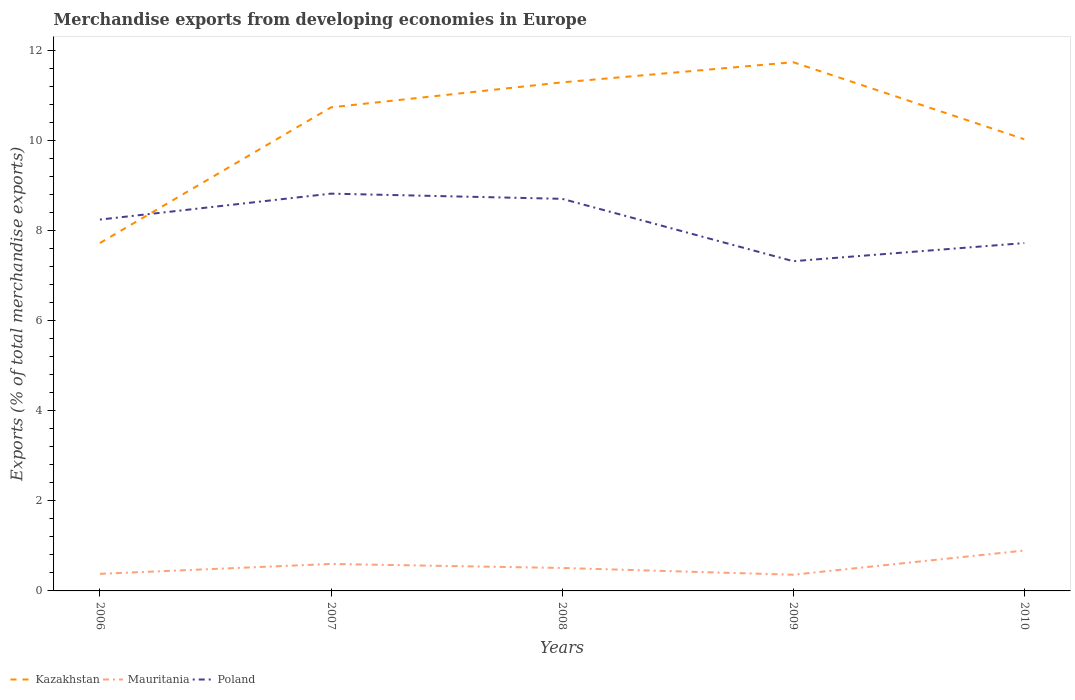How many different coloured lines are there?
Provide a succinct answer. 3. Does the line corresponding to Poland intersect with the line corresponding to Kazakhstan?
Your answer should be very brief. Yes. Across all years, what is the maximum percentage of total merchandise exports in Poland?
Your response must be concise. 7.32. In which year was the percentage of total merchandise exports in Mauritania maximum?
Provide a short and direct response. 2009. What is the total percentage of total merchandise exports in Mauritania in the graph?
Make the answer very short. 0.09. What is the difference between the highest and the second highest percentage of total merchandise exports in Poland?
Your answer should be very brief. 1.5. What is the difference between the highest and the lowest percentage of total merchandise exports in Mauritania?
Make the answer very short. 2. Is the percentage of total merchandise exports in Poland strictly greater than the percentage of total merchandise exports in Kazakhstan over the years?
Make the answer very short. No. How many years are there in the graph?
Ensure brevity in your answer.  5. Does the graph contain grids?
Your answer should be compact. No. What is the title of the graph?
Your answer should be very brief. Merchandise exports from developing economies in Europe. Does "Lithuania" appear as one of the legend labels in the graph?
Provide a succinct answer. No. What is the label or title of the X-axis?
Give a very brief answer. Years. What is the label or title of the Y-axis?
Provide a short and direct response. Exports (% of total merchandise exports). What is the Exports (% of total merchandise exports) in Kazakhstan in 2006?
Your response must be concise. 7.72. What is the Exports (% of total merchandise exports) of Mauritania in 2006?
Your response must be concise. 0.38. What is the Exports (% of total merchandise exports) in Poland in 2006?
Offer a very short reply. 8.24. What is the Exports (% of total merchandise exports) in Kazakhstan in 2007?
Provide a short and direct response. 10.73. What is the Exports (% of total merchandise exports) of Mauritania in 2007?
Offer a very short reply. 0.6. What is the Exports (% of total merchandise exports) in Poland in 2007?
Provide a short and direct response. 8.81. What is the Exports (% of total merchandise exports) in Kazakhstan in 2008?
Make the answer very short. 11.28. What is the Exports (% of total merchandise exports) of Mauritania in 2008?
Your response must be concise. 0.51. What is the Exports (% of total merchandise exports) of Poland in 2008?
Ensure brevity in your answer.  8.7. What is the Exports (% of total merchandise exports) in Kazakhstan in 2009?
Your answer should be very brief. 11.73. What is the Exports (% of total merchandise exports) of Mauritania in 2009?
Ensure brevity in your answer.  0.36. What is the Exports (% of total merchandise exports) in Poland in 2009?
Provide a short and direct response. 7.32. What is the Exports (% of total merchandise exports) of Kazakhstan in 2010?
Your answer should be very brief. 10.02. What is the Exports (% of total merchandise exports) in Mauritania in 2010?
Keep it short and to the point. 0.9. What is the Exports (% of total merchandise exports) in Poland in 2010?
Your response must be concise. 7.72. Across all years, what is the maximum Exports (% of total merchandise exports) of Kazakhstan?
Offer a very short reply. 11.73. Across all years, what is the maximum Exports (% of total merchandise exports) in Mauritania?
Offer a terse response. 0.9. Across all years, what is the maximum Exports (% of total merchandise exports) in Poland?
Your answer should be very brief. 8.81. Across all years, what is the minimum Exports (% of total merchandise exports) in Kazakhstan?
Keep it short and to the point. 7.72. Across all years, what is the minimum Exports (% of total merchandise exports) of Mauritania?
Your answer should be compact. 0.36. Across all years, what is the minimum Exports (% of total merchandise exports) of Poland?
Make the answer very short. 7.32. What is the total Exports (% of total merchandise exports) of Kazakhstan in the graph?
Your answer should be compact. 51.49. What is the total Exports (% of total merchandise exports) in Mauritania in the graph?
Give a very brief answer. 2.74. What is the total Exports (% of total merchandise exports) of Poland in the graph?
Provide a short and direct response. 40.79. What is the difference between the Exports (% of total merchandise exports) in Kazakhstan in 2006 and that in 2007?
Your answer should be very brief. -3.01. What is the difference between the Exports (% of total merchandise exports) of Mauritania in 2006 and that in 2007?
Give a very brief answer. -0.22. What is the difference between the Exports (% of total merchandise exports) of Poland in 2006 and that in 2007?
Your answer should be compact. -0.58. What is the difference between the Exports (% of total merchandise exports) in Kazakhstan in 2006 and that in 2008?
Give a very brief answer. -3.56. What is the difference between the Exports (% of total merchandise exports) of Mauritania in 2006 and that in 2008?
Ensure brevity in your answer.  -0.13. What is the difference between the Exports (% of total merchandise exports) of Poland in 2006 and that in 2008?
Your answer should be compact. -0.46. What is the difference between the Exports (% of total merchandise exports) in Kazakhstan in 2006 and that in 2009?
Keep it short and to the point. -4.01. What is the difference between the Exports (% of total merchandise exports) in Mauritania in 2006 and that in 2009?
Offer a terse response. 0.02. What is the difference between the Exports (% of total merchandise exports) in Poland in 2006 and that in 2009?
Your answer should be compact. 0.92. What is the difference between the Exports (% of total merchandise exports) in Kazakhstan in 2006 and that in 2010?
Your response must be concise. -2.3. What is the difference between the Exports (% of total merchandise exports) of Mauritania in 2006 and that in 2010?
Ensure brevity in your answer.  -0.52. What is the difference between the Exports (% of total merchandise exports) in Poland in 2006 and that in 2010?
Your answer should be very brief. 0.52. What is the difference between the Exports (% of total merchandise exports) of Kazakhstan in 2007 and that in 2008?
Your answer should be very brief. -0.55. What is the difference between the Exports (% of total merchandise exports) in Mauritania in 2007 and that in 2008?
Provide a succinct answer. 0.09. What is the difference between the Exports (% of total merchandise exports) of Poland in 2007 and that in 2008?
Offer a very short reply. 0.12. What is the difference between the Exports (% of total merchandise exports) of Kazakhstan in 2007 and that in 2009?
Your answer should be very brief. -1. What is the difference between the Exports (% of total merchandise exports) of Mauritania in 2007 and that in 2009?
Offer a terse response. 0.24. What is the difference between the Exports (% of total merchandise exports) in Poland in 2007 and that in 2009?
Your answer should be very brief. 1.5. What is the difference between the Exports (% of total merchandise exports) of Kazakhstan in 2007 and that in 2010?
Provide a short and direct response. 0.71. What is the difference between the Exports (% of total merchandise exports) of Mauritania in 2007 and that in 2010?
Provide a short and direct response. -0.3. What is the difference between the Exports (% of total merchandise exports) in Poland in 2007 and that in 2010?
Give a very brief answer. 1.1. What is the difference between the Exports (% of total merchandise exports) in Kazakhstan in 2008 and that in 2009?
Your response must be concise. -0.45. What is the difference between the Exports (% of total merchandise exports) in Mauritania in 2008 and that in 2009?
Give a very brief answer. 0.15. What is the difference between the Exports (% of total merchandise exports) in Poland in 2008 and that in 2009?
Provide a short and direct response. 1.38. What is the difference between the Exports (% of total merchandise exports) in Kazakhstan in 2008 and that in 2010?
Your answer should be compact. 1.26. What is the difference between the Exports (% of total merchandise exports) in Mauritania in 2008 and that in 2010?
Your answer should be very brief. -0.39. What is the difference between the Exports (% of total merchandise exports) in Poland in 2008 and that in 2010?
Keep it short and to the point. 0.98. What is the difference between the Exports (% of total merchandise exports) in Kazakhstan in 2009 and that in 2010?
Offer a terse response. 1.71. What is the difference between the Exports (% of total merchandise exports) in Mauritania in 2009 and that in 2010?
Provide a succinct answer. -0.54. What is the difference between the Exports (% of total merchandise exports) of Poland in 2009 and that in 2010?
Your response must be concise. -0.4. What is the difference between the Exports (% of total merchandise exports) of Kazakhstan in 2006 and the Exports (% of total merchandise exports) of Mauritania in 2007?
Offer a very short reply. 7.12. What is the difference between the Exports (% of total merchandise exports) in Kazakhstan in 2006 and the Exports (% of total merchandise exports) in Poland in 2007?
Provide a succinct answer. -1.1. What is the difference between the Exports (% of total merchandise exports) in Mauritania in 2006 and the Exports (% of total merchandise exports) in Poland in 2007?
Ensure brevity in your answer.  -8.44. What is the difference between the Exports (% of total merchandise exports) in Kazakhstan in 2006 and the Exports (% of total merchandise exports) in Mauritania in 2008?
Your answer should be very brief. 7.21. What is the difference between the Exports (% of total merchandise exports) of Kazakhstan in 2006 and the Exports (% of total merchandise exports) of Poland in 2008?
Offer a terse response. -0.98. What is the difference between the Exports (% of total merchandise exports) in Mauritania in 2006 and the Exports (% of total merchandise exports) in Poland in 2008?
Provide a succinct answer. -8.32. What is the difference between the Exports (% of total merchandise exports) in Kazakhstan in 2006 and the Exports (% of total merchandise exports) in Mauritania in 2009?
Keep it short and to the point. 7.36. What is the difference between the Exports (% of total merchandise exports) of Kazakhstan in 2006 and the Exports (% of total merchandise exports) of Poland in 2009?
Provide a short and direct response. 0.4. What is the difference between the Exports (% of total merchandise exports) of Mauritania in 2006 and the Exports (% of total merchandise exports) of Poland in 2009?
Your answer should be very brief. -6.94. What is the difference between the Exports (% of total merchandise exports) of Kazakhstan in 2006 and the Exports (% of total merchandise exports) of Mauritania in 2010?
Provide a succinct answer. 6.82. What is the difference between the Exports (% of total merchandise exports) of Kazakhstan in 2006 and the Exports (% of total merchandise exports) of Poland in 2010?
Your answer should be compact. 0. What is the difference between the Exports (% of total merchandise exports) of Mauritania in 2006 and the Exports (% of total merchandise exports) of Poland in 2010?
Provide a succinct answer. -7.34. What is the difference between the Exports (% of total merchandise exports) in Kazakhstan in 2007 and the Exports (% of total merchandise exports) in Mauritania in 2008?
Offer a very short reply. 10.22. What is the difference between the Exports (% of total merchandise exports) of Kazakhstan in 2007 and the Exports (% of total merchandise exports) of Poland in 2008?
Keep it short and to the point. 2.03. What is the difference between the Exports (% of total merchandise exports) in Mauritania in 2007 and the Exports (% of total merchandise exports) in Poland in 2008?
Keep it short and to the point. -8.1. What is the difference between the Exports (% of total merchandise exports) of Kazakhstan in 2007 and the Exports (% of total merchandise exports) of Mauritania in 2009?
Provide a short and direct response. 10.37. What is the difference between the Exports (% of total merchandise exports) in Kazakhstan in 2007 and the Exports (% of total merchandise exports) in Poland in 2009?
Make the answer very short. 3.41. What is the difference between the Exports (% of total merchandise exports) in Mauritania in 2007 and the Exports (% of total merchandise exports) in Poland in 2009?
Offer a terse response. -6.72. What is the difference between the Exports (% of total merchandise exports) of Kazakhstan in 2007 and the Exports (% of total merchandise exports) of Mauritania in 2010?
Keep it short and to the point. 9.83. What is the difference between the Exports (% of total merchandise exports) of Kazakhstan in 2007 and the Exports (% of total merchandise exports) of Poland in 2010?
Offer a terse response. 3.01. What is the difference between the Exports (% of total merchandise exports) of Mauritania in 2007 and the Exports (% of total merchandise exports) of Poland in 2010?
Make the answer very short. -7.12. What is the difference between the Exports (% of total merchandise exports) of Kazakhstan in 2008 and the Exports (% of total merchandise exports) of Mauritania in 2009?
Ensure brevity in your answer.  10.92. What is the difference between the Exports (% of total merchandise exports) in Kazakhstan in 2008 and the Exports (% of total merchandise exports) in Poland in 2009?
Provide a short and direct response. 3.97. What is the difference between the Exports (% of total merchandise exports) of Mauritania in 2008 and the Exports (% of total merchandise exports) of Poland in 2009?
Ensure brevity in your answer.  -6.81. What is the difference between the Exports (% of total merchandise exports) of Kazakhstan in 2008 and the Exports (% of total merchandise exports) of Mauritania in 2010?
Keep it short and to the point. 10.39. What is the difference between the Exports (% of total merchandise exports) in Kazakhstan in 2008 and the Exports (% of total merchandise exports) in Poland in 2010?
Provide a succinct answer. 3.57. What is the difference between the Exports (% of total merchandise exports) in Mauritania in 2008 and the Exports (% of total merchandise exports) in Poland in 2010?
Your answer should be very brief. -7.21. What is the difference between the Exports (% of total merchandise exports) of Kazakhstan in 2009 and the Exports (% of total merchandise exports) of Mauritania in 2010?
Your response must be concise. 10.84. What is the difference between the Exports (% of total merchandise exports) in Kazakhstan in 2009 and the Exports (% of total merchandise exports) in Poland in 2010?
Your answer should be very brief. 4.01. What is the difference between the Exports (% of total merchandise exports) of Mauritania in 2009 and the Exports (% of total merchandise exports) of Poland in 2010?
Keep it short and to the point. -7.36. What is the average Exports (% of total merchandise exports) of Kazakhstan per year?
Provide a succinct answer. 10.3. What is the average Exports (% of total merchandise exports) in Mauritania per year?
Provide a short and direct response. 0.55. What is the average Exports (% of total merchandise exports) of Poland per year?
Your answer should be compact. 8.16. In the year 2006, what is the difference between the Exports (% of total merchandise exports) of Kazakhstan and Exports (% of total merchandise exports) of Mauritania?
Your response must be concise. 7.34. In the year 2006, what is the difference between the Exports (% of total merchandise exports) in Kazakhstan and Exports (% of total merchandise exports) in Poland?
Offer a terse response. -0.52. In the year 2006, what is the difference between the Exports (% of total merchandise exports) of Mauritania and Exports (% of total merchandise exports) of Poland?
Keep it short and to the point. -7.86. In the year 2007, what is the difference between the Exports (% of total merchandise exports) in Kazakhstan and Exports (% of total merchandise exports) in Mauritania?
Ensure brevity in your answer.  10.13. In the year 2007, what is the difference between the Exports (% of total merchandise exports) of Kazakhstan and Exports (% of total merchandise exports) of Poland?
Keep it short and to the point. 1.91. In the year 2007, what is the difference between the Exports (% of total merchandise exports) in Mauritania and Exports (% of total merchandise exports) in Poland?
Your response must be concise. -8.22. In the year 2008, what is the difference between the Exports (% of total merchandise exports) of Kazakhstan and Exports (% of total merchandise exports) of Mauritania?
Provide a succinct answer. 10.77. In the year 2008, what is the difference between the Exports (% of total merchandise exports) of Kazakhstan and Exports (% of total merchandise exports) of Poland?
Offer a very short reply. 2.58. In the year 2008, what is the difference between the Exports (% of total merchandise exports) in Mauritania and Exports (% of total merchandise exports) in Poland?
Offer a very short reply. -8.19. In the year 2009, what is the difference between the Exports (% of total merchandise exports) of Kazakhstan and Exports (% of total merchandise exports) of Mauritania?
Make the answer very short. 11.37. In the year 2009, what is the difference between the Exports (% of total merchandise exports) of Kazakhstan and Exports (% of total merchandise exports) of Poland?
Your answer should be very brief. 4.42. In the year 2009, what is the difference between the Exports (% of total merchandise exports) in Mauritania and Exports (% of total merchandise exports) in Poland?
Offer a terse response. -6.96. In the year 2010, what is the difference between the Exports (% of total merchandise exports) in Kazakhstan and Exports (% of total merchandise exports) in Mauritania?
Provide a succinct answer. 9.13. In the year 2010, what is the difference between the Exports (% of total merchandise exports) in Kazakhstan and Exports (% of total merchandise exports) in Poland?
Provide a short and direct response. 2.3. In the year 2010, what is the difference between the Exports (% of total merchandise exports) in Mauritania and Exports (% of total merchandise exports) in Poland?
Offer a terse response. -6.82. What is the ratio of the Exports (% of total merchandise exports) of Kazakhstan in 2006 to that in 2007?
Provide a short and direct response. 0.72. What is the ratio of the Exports (% of total merchandise exports) in Mauritania in 2006 to that in 2007?
Offer a very short reply. 0.63. What is the ratio of the Exports (% of total merchandise exports) of Poland in 2006 to that in 2007?
Keep it short and to the point. 0.93. What is the ratio of the Exports (% of total merchandise exports) in Kazakhstan in 2006 to that in 2008?
Provide a short and direct response. 0.68. What is the ratio of the Exports (% of total merchandise exports) of Mauritania in 2006 to that in 2008?
Offer a very short reply. 0.74. What is the ratio of the Exports (% of total merchandise exports) of Poland in 2006 to that in 2008?
Your answer should be very brief. 0.95. What is the ratio of the Exports (% of total merchandise exports) in Kazakhstan in 2006 to that in 2009?
Your response must be concise. 0.66. What is the ratio of the Exports (% of total merchandise exports) of Mauritania in 2006 to that in 2009?
Your answer should be compact. 1.05. What is the ratio of the Exports (% of total merchandise exports) of Poland in 2006 to that in 2009?
Your response must be concise. 1.13. What is the ratio of the Exports (% of total merchandise exports) of Kazakhstan in 2006 to that in 2010?
Make the answer very short. 0.77. What is the ratio of the Exports (% of total merchandise exports) in Mauritania in 2006 to that in 2010?
Provide a succinct answer. 0.42. What is the ratio of the Exports (% of total merchandise exports) of Poland in 2006 to that in 2010?
Provide a short and direct response. 1.07. What is the ratio of the Exports (% of total merchandise exports) in Kazakhstan in 2007 to that in 2008?
Your answer should be very brief. 0.95. What is the ratio of the Exports (% of total merchandise exports) in Mauritania in 2007 to that in 2008?
Provide a short and direct response. 1.18. What is the ratio of the Exports (% of total merchandise exports) in Poland in 2007 to that in 2008?
Provide a succinct answer. 1.01. What is the ratio of the Exports (% of total merchandise exports) in Kazakhstan in 2007 to that in 2009?
Offer a terse response. 0.91. What is the ratio of the Exports (% of total merchandise exports) of Mauritania in 2007 to that in 2009?
Give a very brief answer. 1.67. What is the ratio of the Exports (% of total merchandise exports) in Poland in 2007 to that in 2009?
Provide a short and direct response. 1.2. What is the ratio of the Exports (% of total merchandise exports) in Kazakhstan in 2007 to that in 2010?
Keep it short and to the point. 1.07. What is the ratio of the Exports (% of total merchandise exports) of Mauritania in 2007 to that in 2010?
Provide a succinct answer. 0.67. What is the ratio of the Exports (% of total merchandise exports) in Poland in 2007 to that in 2010?
Make the answer very short. 1.14. What is the ratio of the Exports (% of total merchandise exports) in Kazakhstan in 2008 to that in 2009?
Your answer should be compact. 0.96. What is the ratio of the Exports (% of total merchandise exports) of Mauritania in 2008 to that in 2009?
Your answer should be very brief. 1.42. What is the ratio of the Exports (% of total merchandise exports) in Poland in 2008 to that in 2009?
Ensure brevity in your answer.  1.19. What is the ratio of the Exports (% of total merchandise exports) of Kazakhstan in 2008 to that in 2010?
Your answer should be very brief. 1.13. What is the ratio of the Exports (% of total merchandise exports) of Mauritania in 2008 to that in 2010?
Your answer should be compact. 0.57. What is the ratio of the Exports (% of total merchandise exports) of Poland in 2008 to that in 2010?
Ensure brevity in your answer.  1.13. What is the ratio of the Exports (% of total merchandise exports) in Kazakhstan in 2009 to that in 2010?
Your answer should be compact. 1.17. What is the ratio of the Exports (% of total merchandise exports) in Mauritania in 2009 to that in 2010?
Make the answer very short. 0.4. What is the ratio of the Exports (% of total merchandise exports) of Poland in 2009 to that in 2010?
Your answer should be compact. 0.95. What is the difference between the highest and the second highest Exports (% of total merchandise exports) of Kazakhstan?
Make the answer very short. 0.45. What is the difference between the highest and the second highest Exports (% of total merchandise exports) of Mauritania?
Your answer should be very brief. 0.3. What is the difference between the highest and the second highest Exports (% of total merchandise exports) in Poland?
Offer a very short reply. 0.12. What is the difference between the highest and the lowest Exports (% of total merchandise exports) of Kazakhstan?
Give a very brief answer. 4.01. What is the difference between the highest and the lowest Exports (% of total merchandise exports) in Mauritania?
Your response must be concise. 0.54. What is the difference between the highest and the lowest Exports (% of total merchandise exports) in Poland?
Offer a very short reply. 1.5. 